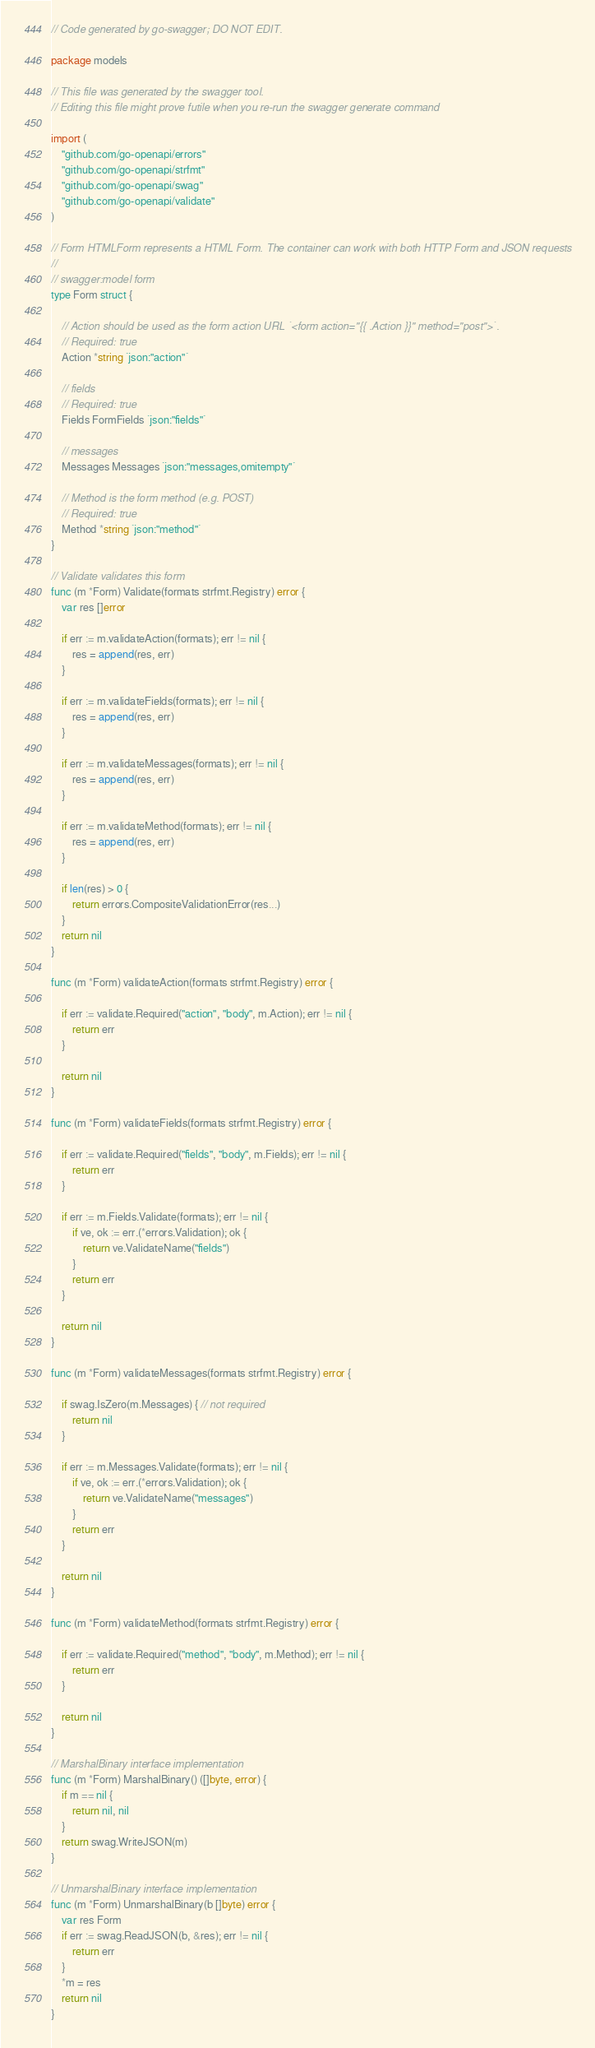Convert code to text. <code><loc_0><loc_0><loc_500><loc_500><_Go_>// Code generated by go-swagger; DO NOT EDIT.

package models

// This file was generated by the swagger tool.
// Editing this file might prove futile when you re-run the swagger generate command

import (
	"github.com/go-openapi/errors"
	"github.com/go-openapi/strfmt"
	"github.com/go-openapi/swag"
	"github.com/go-openapi/validate"
)

// Form HTMLForm represents a HTML Form. The container can work with both HTTP Form and JSON requests
//
// swagger:model form
type Form struct {

	// Action should be used as the form action URL `<form action="{{ .Action }}" method="post">`.
	// Required: true
	Action *string `json:"action"`

	// fields
	// Required: true
	Fields FormFields `json:"fields"`

	// messages
	Messages Messages `json:"messages,omitempty"`

	// Method is the form method (e.g. POST)
	// Required: true
	Method *string `json:"method"`
}

// Validate validates this form
func (m *Form) Validate(formats strfmt.Registry) error {
	var res []error

	if err := m.validateAction(formats); err != nil {
		res = append(res, err)
	}

	if err := m.validateFields(formats); err != nil {
		res = append(res, err)
	}

	if err := m.validateMessages(formats); err != nil {
		res = append(res, err)
	}

	if err := m.validateMethod(formats); err != nil {
		res = append(res, err)
	}

	if len(res) > 0 {
		return errors.CompositeValidationError(res...)
	}
	return nil
}

func (m *Form) validateAction(formats strfmt.Registry) error {

	if err := validate.Required("action", "body", m.Action); err != nil {
		return err
	}

	return nil
}

func (m *Form) validateFields(formats strfmt.Registry) error {

	if err := validate.Required("fields", "body", m.Fields); err != nil {
		return err
	}

	if err := m.Fields.Validate(formats); err != nil {
		if ve, ok := err.(*errors.Validation); ok {
			return ve.ValidateName("fields")
		}
		return err
	}

	return nil
}

func (m *Form) validateMessages(formats strfmt.Registry) error {

	if swag.IsZero(m.Messages) { // not required
		return nil
	}

	if err := m.Messages.Validate(formats); err != nil {
		if ve, ok := err.(*errors.Validation); ok {
			return ve.ValidateName("messages")
		}
		return err
	}

	return nil
}

func (m *Form) validateMethod(formats strfmt.Registry) error {

	if err := validate.Required("method", "body", m.Method); err != nil {
		return err
	}

	return nil
}

// MarshalBinary interface implementation
func (m *Form) MarshalBinary() ([]byte, error) {
	if m == nil {
		return nil, nil
	}
	return swag.WriteJSON(m)
}

// UnmarshalBinary interface implementation
func (m *Form) UnmarshalBinary(b []byte) error {
	var res Form
	if err := swag.ReadJSON(b, &res); err != nil {
		return err
	}
	*m = res
	return nil
}
</code> 